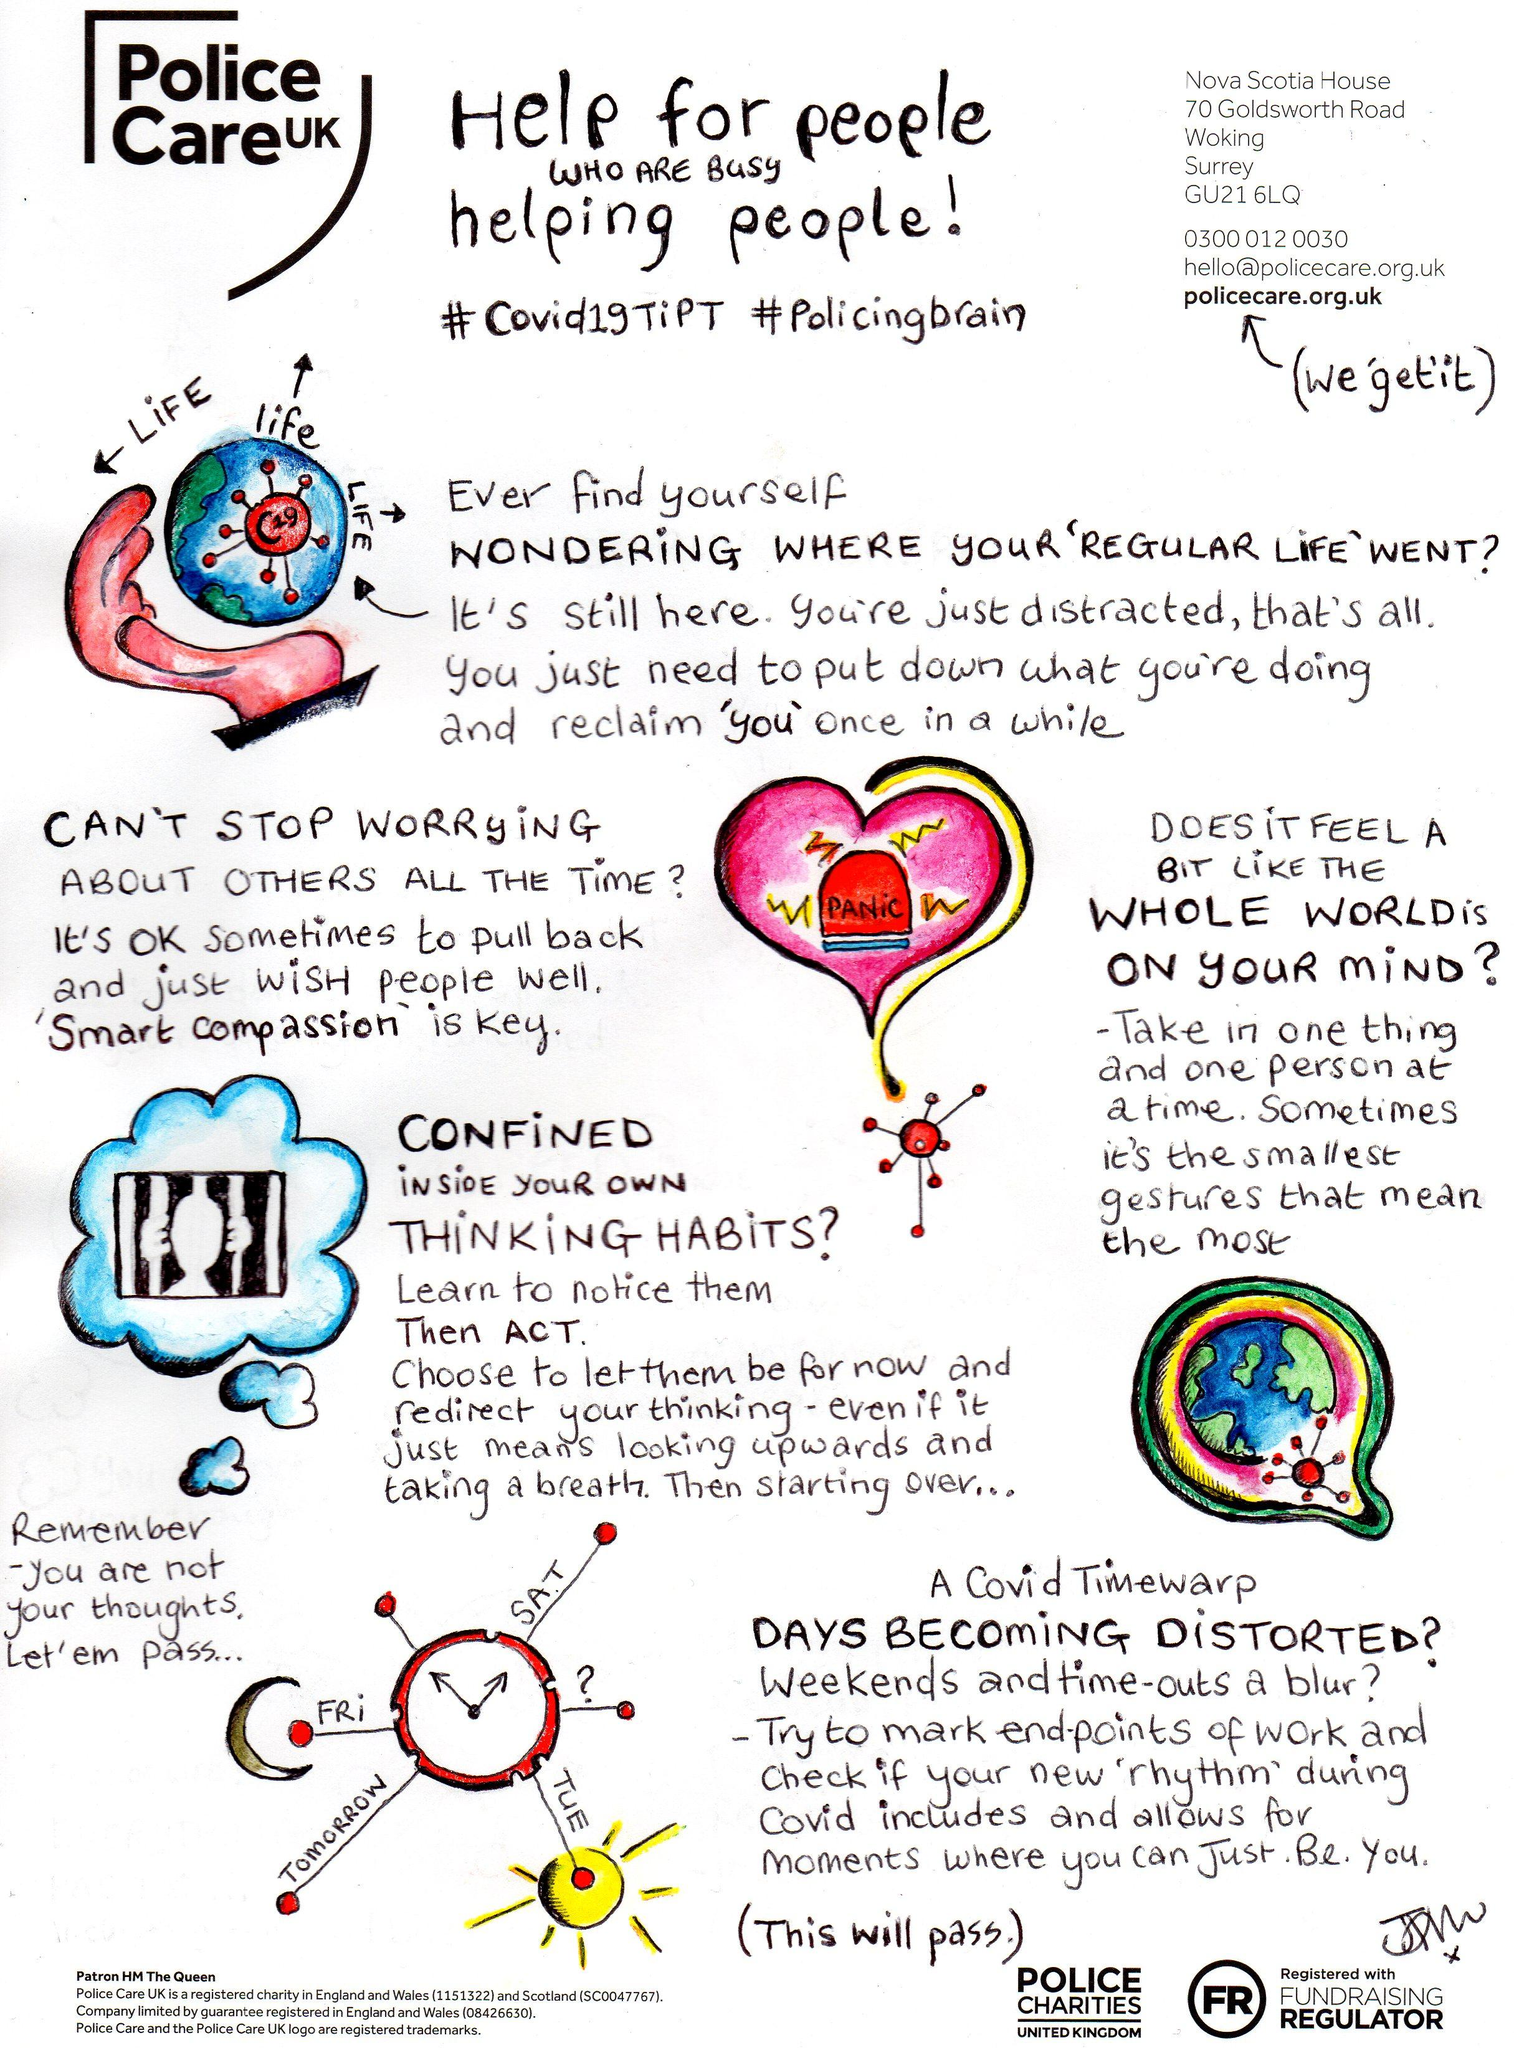Mention a couple of crucial points in this snapshot. The image of the heart contains the word "Panic. The people who are always busy helping others are the police. After learning to recognize your thinking habits, it is important to take action and make changes to your thought patterns. The two hashtags used for Police care UK are #Covid19TiPT and #policingbrain. The key to stopping worry about other people all the time is smart compassion. 